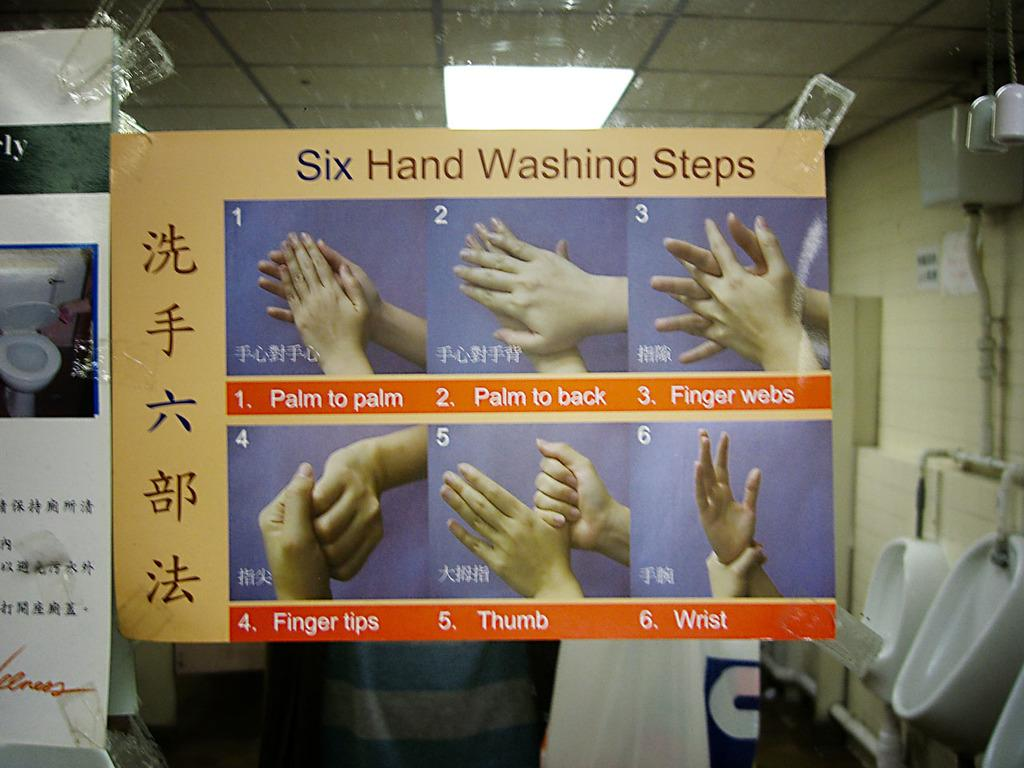<image>
Relay a brief, clear account of the picture shown. paper showing pictures of hands and the words "Six Hand Washing Steps" on top. 